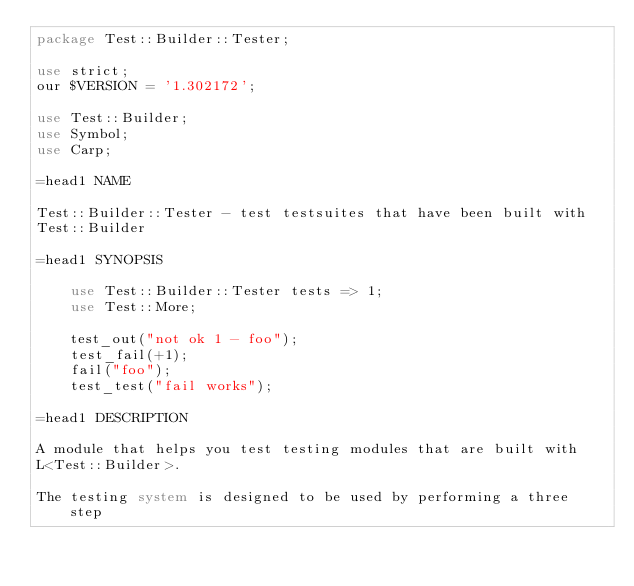Convert code to text. <code><loc_0><loc_0><loc_500><loc_500><_Perl_>package Test::Builder::Tester;

use strict;
our $VERSION = '1.302172';

use Test::Builder;
use Symbol;
use Carp;

=head1 NAME

Test::Builder::Tester - test testsuites that have been built with
Test::Builder

=head1 SYNOPSIS

    use Test::Builder::Tester tests => 1;
    use Test::More;

    test_out("not ok 1 - foo");
    test_fail(+1);
    fail("foo");
    test_test("fail works");

=head1 DESCRIPTION

A module that helps you test testing modules that are built with
L<Test::Builder>.

The testing system is designed to be used by performing a three step</code> 